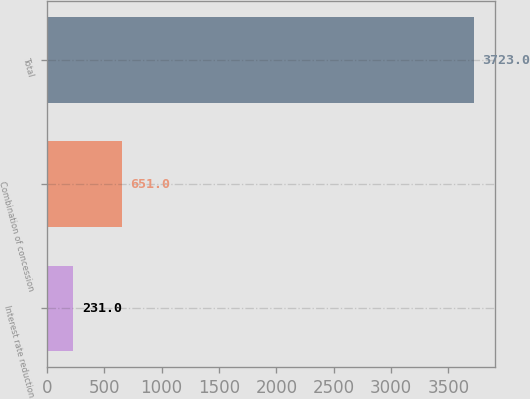Convert chart to OTSL. <chart><loc_0><loc_0><loc_500><loc_500><bar_chart><fcel>Interest rate reduction<fcel>Combination of concession<fcel>Total<nl><fcel>231<fcel>651<fcel>3723<nl></chart> 